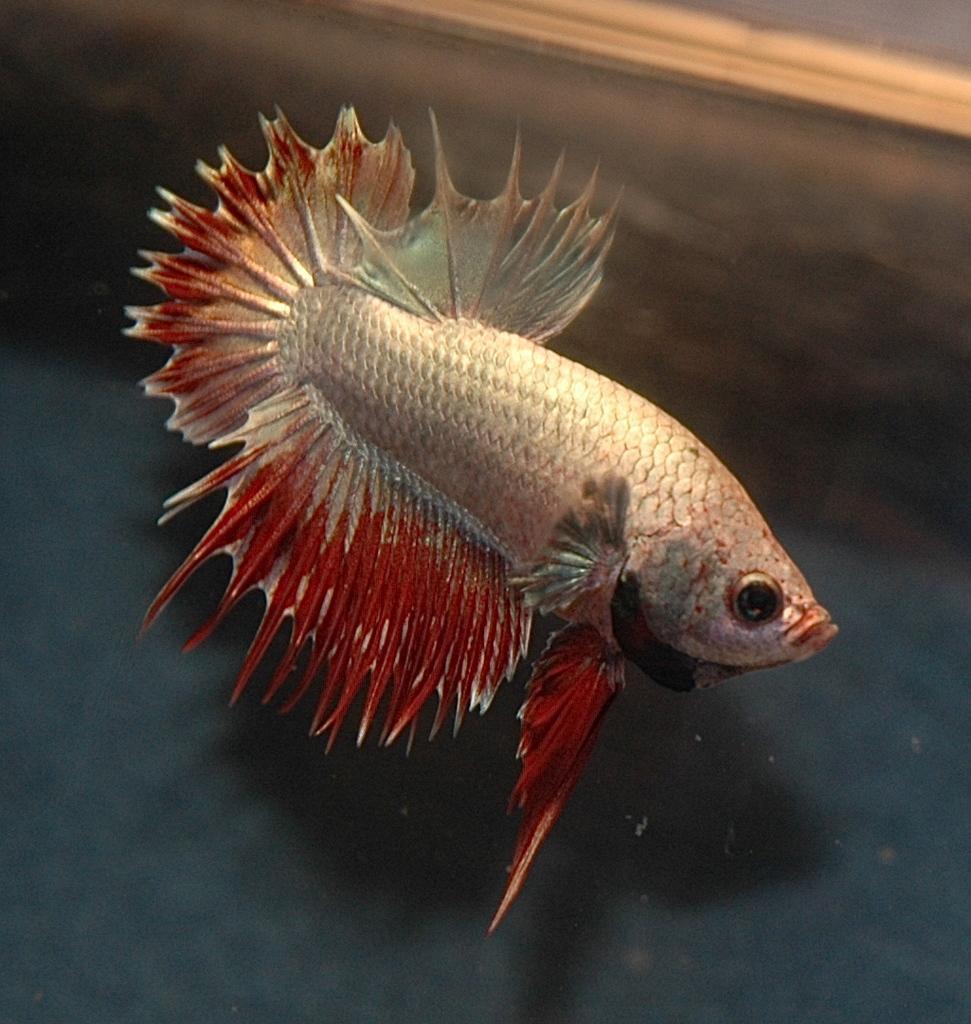Please provide a concise description of this image. In the center of the image we can see a fish in the water. 